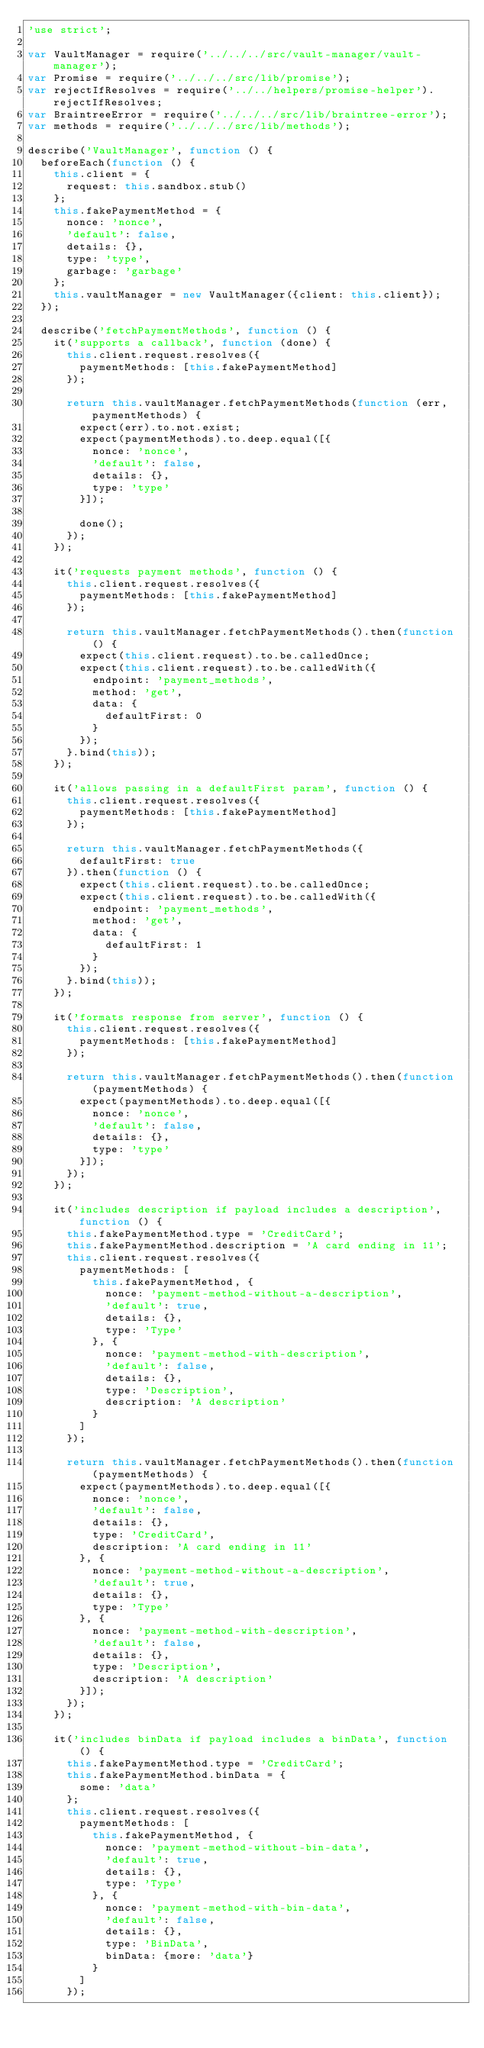Convert code to text. <code><loc_0><loc_0><loc_500><loc_500><_JavaScript_>'use strict';

var VaultManager = require('../../../src/vault-manager/vault-manager');
var Promise = require('../../../src/lib/promise');
var rejectIfResolves = require('../../helpers/promise-helper').rejectIfResolves;
var BraintreeError = require('../../../src/lib/braintree-error');
var methods = require('../../../src/lib/methods');

describe('VaultManager', function () {
  beforeEach(function () {
    this.client = {
      request: this.sandbox.stub()
    };
    this.fakePaymentMethod = {
      nonce: 'nonce',
      'default': false,
      details: {},
      type: 'type',
      garbage: 'garbage'
    };
    this.vaultManager = new VaultManager({client: this.client});
  });

  describe('fetchPaymentMethods', function () {
    it('supports a callback', function (done) {
      this.client.request.resolves({
        paymentMethods: [this.fakePaymentMethod]
      });

      return this.vaultManager.fetchPaymentMethods(function (err, paymentMethods) {
        expect(err).to.not.exist;
        expect(paymentMethods).to.deep.equal([{
          nonce: 'nonce',
          'default': false,
          details: {},
          type: 'type'
        }]);

        done();
      });
    });

    it('requests payment methods', function () {
      this.client.request.resolves({
        paymentMethods: [this.fakePaymentMethod]
      });

      return this.vaultManager.fetchPaymentMethods().then(function () {
        expect(this.client.request).to.be.calledOnce;
        expect(this.client.request).to.be.calledWith({
          endpoint: 'payment_methods',
          method: 'get',
          data: {
            defaultFirst: 0
          }
        });
      }.bind(this));
    });

    it('allows passing in a defaultFirst param', function () {
      this.client.request.resolves({
        paymentMethods: [this.fakePaymentMethod]
      });

      return this.vaultManager.fetchPaymentMethods({
        defaultFirst: true
      }).then(function () {
        expect(this.client.request).to.be.calledOnce;
        expect(this.client.request).to.be.calledWith({
          endpoint: 'payment_methods',
          method: 'get',
          data: {
            defaultFirst: 1
          }
        });
      }.bind(this));
    });

    it('formats response from server', function () {
      this.client.request.resolves({
        paymentMethods: [this.fakePaymentMethod]
      });

      return this.vaultManager.fetchPaymentMethods().then(function (paymentMethods) {
        expect(paymentMethods).to.deep.equal([{
          nonce: 'nonce',
          'default': false,
          details: {},
          type: 'type'
        }]);
      });
    });

    it('includes description if payload includes a description', function () {
      this.fakePaymentMethod.type = 'CreditCard';
      this.fakePaymentMethod.description = 'A card ending in 11';
      this.client.request.resolves({
        paymentMethods: [
          this.fakePaymentMethod, {
            nonce: 'payment-method-without-a-description',
            'default': true,
            details: {},
            type: 'Type'
          }, {
            nonce: 'payment-method-with-description',
            'default': false,
            details: {},
            type: 'Description',
            description: 'A description'
          }
        ]
      });

      return this.vaultManager.fetchPaymentMethods().then(function (paymentMethods) {
        expect(paymentMethods).to.deep.equal([{
          nonce: 'nonce',
          'default': false,
          details: {},
          type: 'CreditCard',
          description: 'A card ending in 11'
        }, {
          nonce: 'payment-method-without-a-description',
          'default': true,
          details: {},
          type: 'Type'
        }, {
          nonce: 'payment-method-with-description',
          'default': false,
          details: {},
          type: 'Description',
          description: 'A description'
        }]);
      });
    });

    it('includes binData if payload includes a binData', function () {
      this.fakePaymentMethod.type = 'CreditCard';
      this.fakePaymentMethod.binData = {
        some: 'data'
      };
      this.client.request.resolves({
        paymentMethods: [
          this.fakePaymentMethod, {
            nonce: 'payment-method-without-bin-data',
            'default': true,
            details: {},
            type: 'Type'
          }, {
            nonce: 'payment-method-with-bin-data',
            'default': false,
            details: {},
            type: 'BinData',
            binData: {more: 'data'}
          }
        ]
      });
</code> 